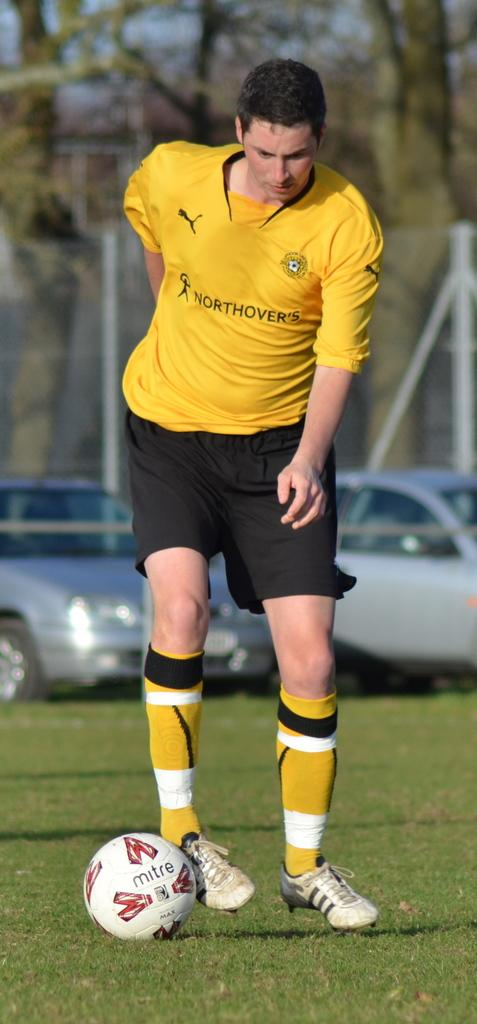What is the man in the image doing? The man is playing football in the image. What else can be seen in the image besides the man playing football? There are cars parked and trees visible in the image. What type of record is the man breaking while playing football in the image? There is no mention of a record or any record-breaking activity in the image. 